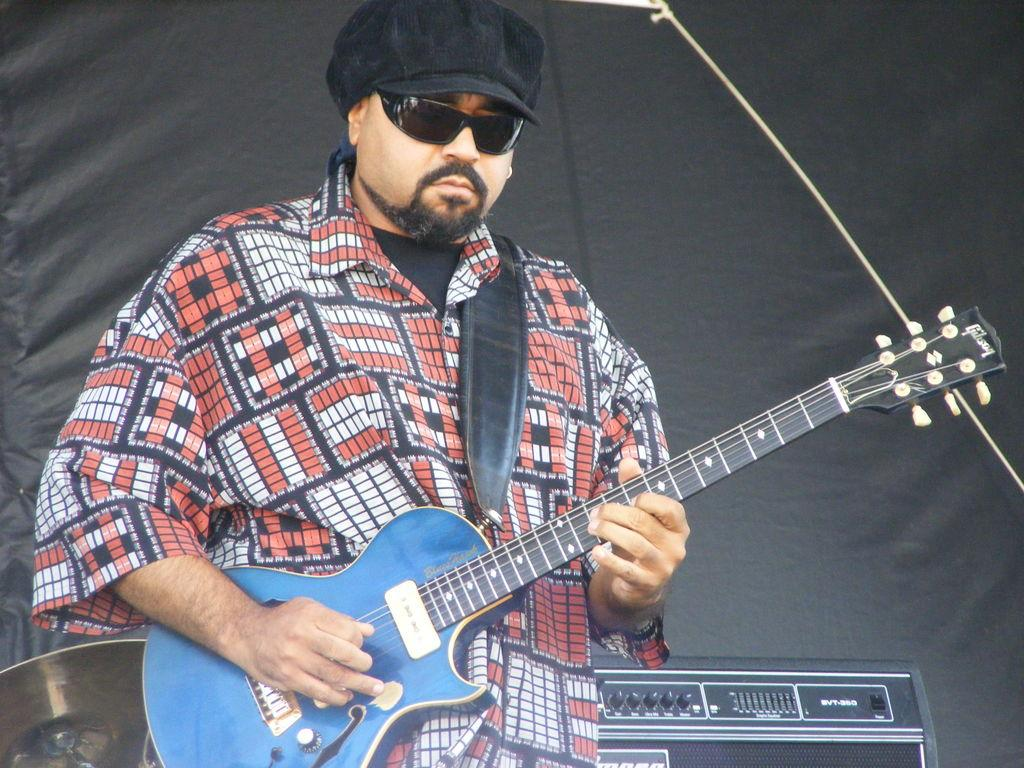Who is present in the image? There is a man in the image. What is the man wearing on his head? The man is wearing a cap. What is the man holding in the image? The man is holding a guitar. What can be seen in the background of the image? There is equipment visible in the background of the image. What type of birthday decoration is hanging from the man's cap in the image? There is no birthday decoration or any indication of a birthday celebration in the image. 